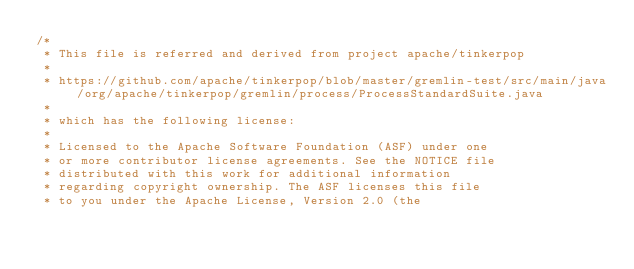<code> <loc_0><loc_0><loc_500><loc_500><_Java_>/*
 * This file is referred and derived from project apache/tinkerpop
 *
 * https://github.com/apache/tinkerpop/blob/master/gremlin-test/src/main/java/org/apache/tinkerpop/gremlin/process/ProcessStandardSuite.java
 *
 * which has the following license:
 *
 * Licensed to the Apache Software Foundation (ASF) under one
 * or more contributor license agreements. See the NOTICE file
 * distributed with this work for additional information
 * regarding copyright ownership. The ASF licenses this file
 * to you under the Apache License, Version 2.0 (the</code> 